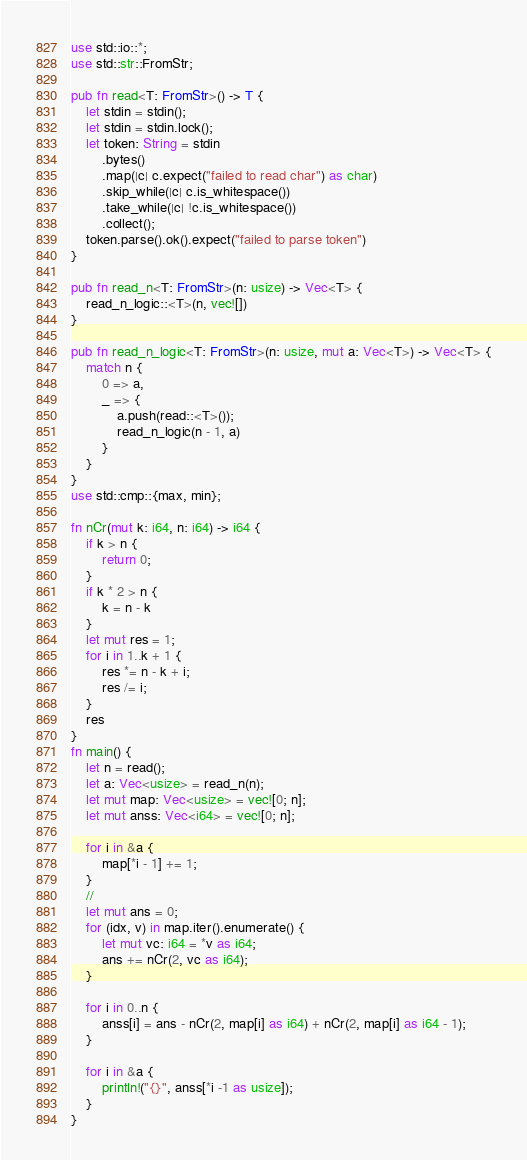<code> <loc_0><loc_0><loc_500><loc_500><_Rust_>use std::io::*;
use std::str::FromStr;

pub fn read<T: FromStr>() -> T {
    let stdin = stdin();
    let stdin = stdin.lock();
    let token: String = stdin
        .bytes()
        .map(|c| c.expect("failed to read char") as char)
        .skip_while(|c| c.is_whitespace())
        .take_while(|c| !c.is_whitespace())
        .collect();
    token.parse().ok().expect("failed to parse token")
}

pub fn read_n<T: FromStr>(n: usize) -> Vec<T> {
    read_n_logic::<T>(n, vec![])
}

pub fn read_n_logic<T: FromStr>(n: usize, mut a: Vec<T>) -> Vec<T> {
    match n {
        0 => a,
        _ => {
            a.push(read::<T>());
            read_n_logic(n - 1, a)
        }
    }
}
use std::cmp::{max, min};

fn nCr(mut k: i64, n: i64) -> i64 {
    if k > n {
        return 0;
    }
    if k * 2 > n {
        k = n - k
    }
    let mut res = 1;
    for i in 1..k + 1 {
        res *= n - k + i;
        res /= i;
    }
    res
}
fn main() {
    let n = read();
    let a: Vec<usize> = read_n(n);
    let mut map: Vec<usize> = vec![0; n];
    let mut anss: Vec<i64> = vec![0; n];

    for i in &a {
        map[*i - 1] += 1;
    }
    //
    let mut ans = 0;
    for (idx, v) in map.iter().enumerate() {
        let mut vc: i64 = *v as i64;
        ans += nCr(2, vc as i64);
    }

    for i in 0..n {
        anss[i] = ans - nCr(2, map[i] as i64) + nCr(2, map[i] as i64 - 1);
    }

    for i in &a {
        println!("{}", anss[*i -1 as usize]);
    }
}
</code> 